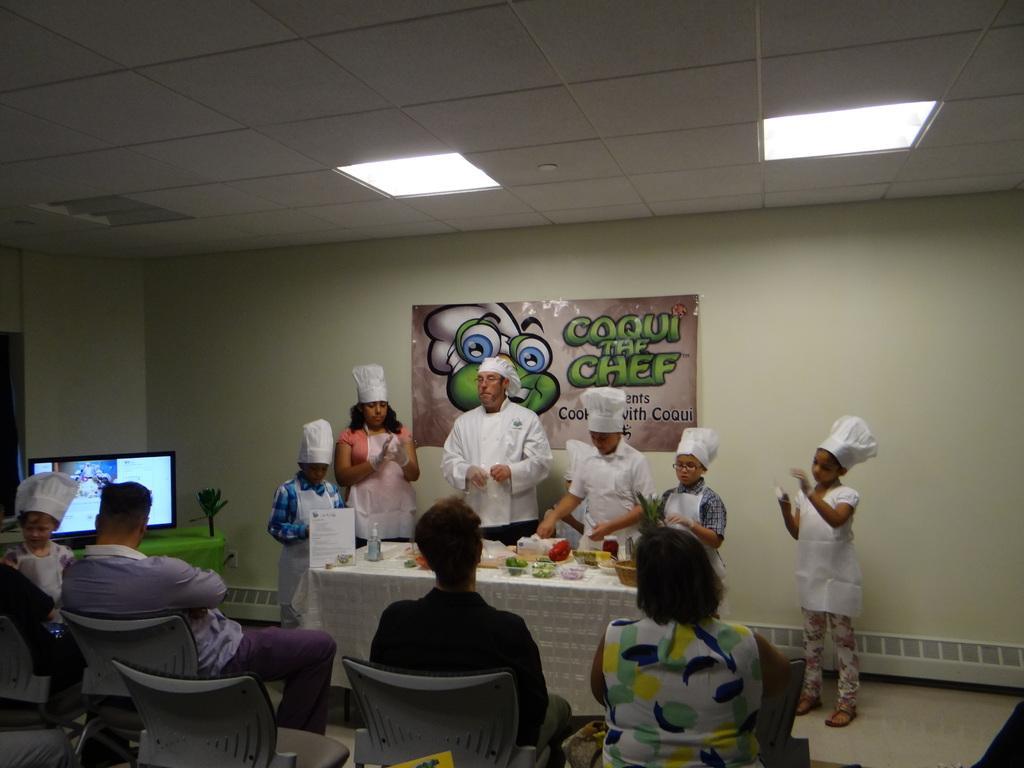Please provide a concise description of this image. In the image there are kids and man stood at wall wearing chef dress with food in front of them on a table. In the back people sat on chairs looking at them. 